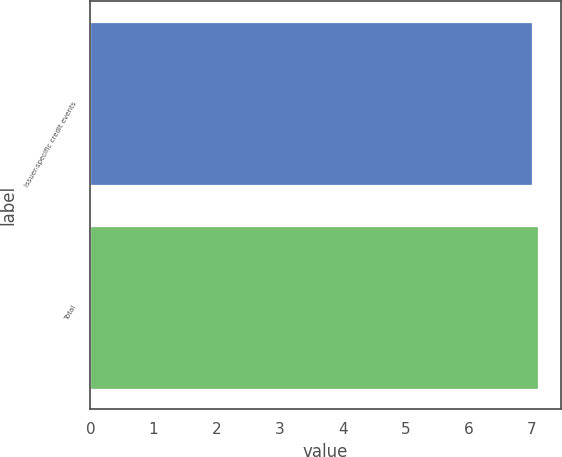Convert chart to OTSL. <chart><loc_0><loc_0><loc_500><loc_500><bar_chart><fcel>Issuer-specific credit events<fcel>Total<nl><fcel>7<fcel>7.1<nl></chart> 